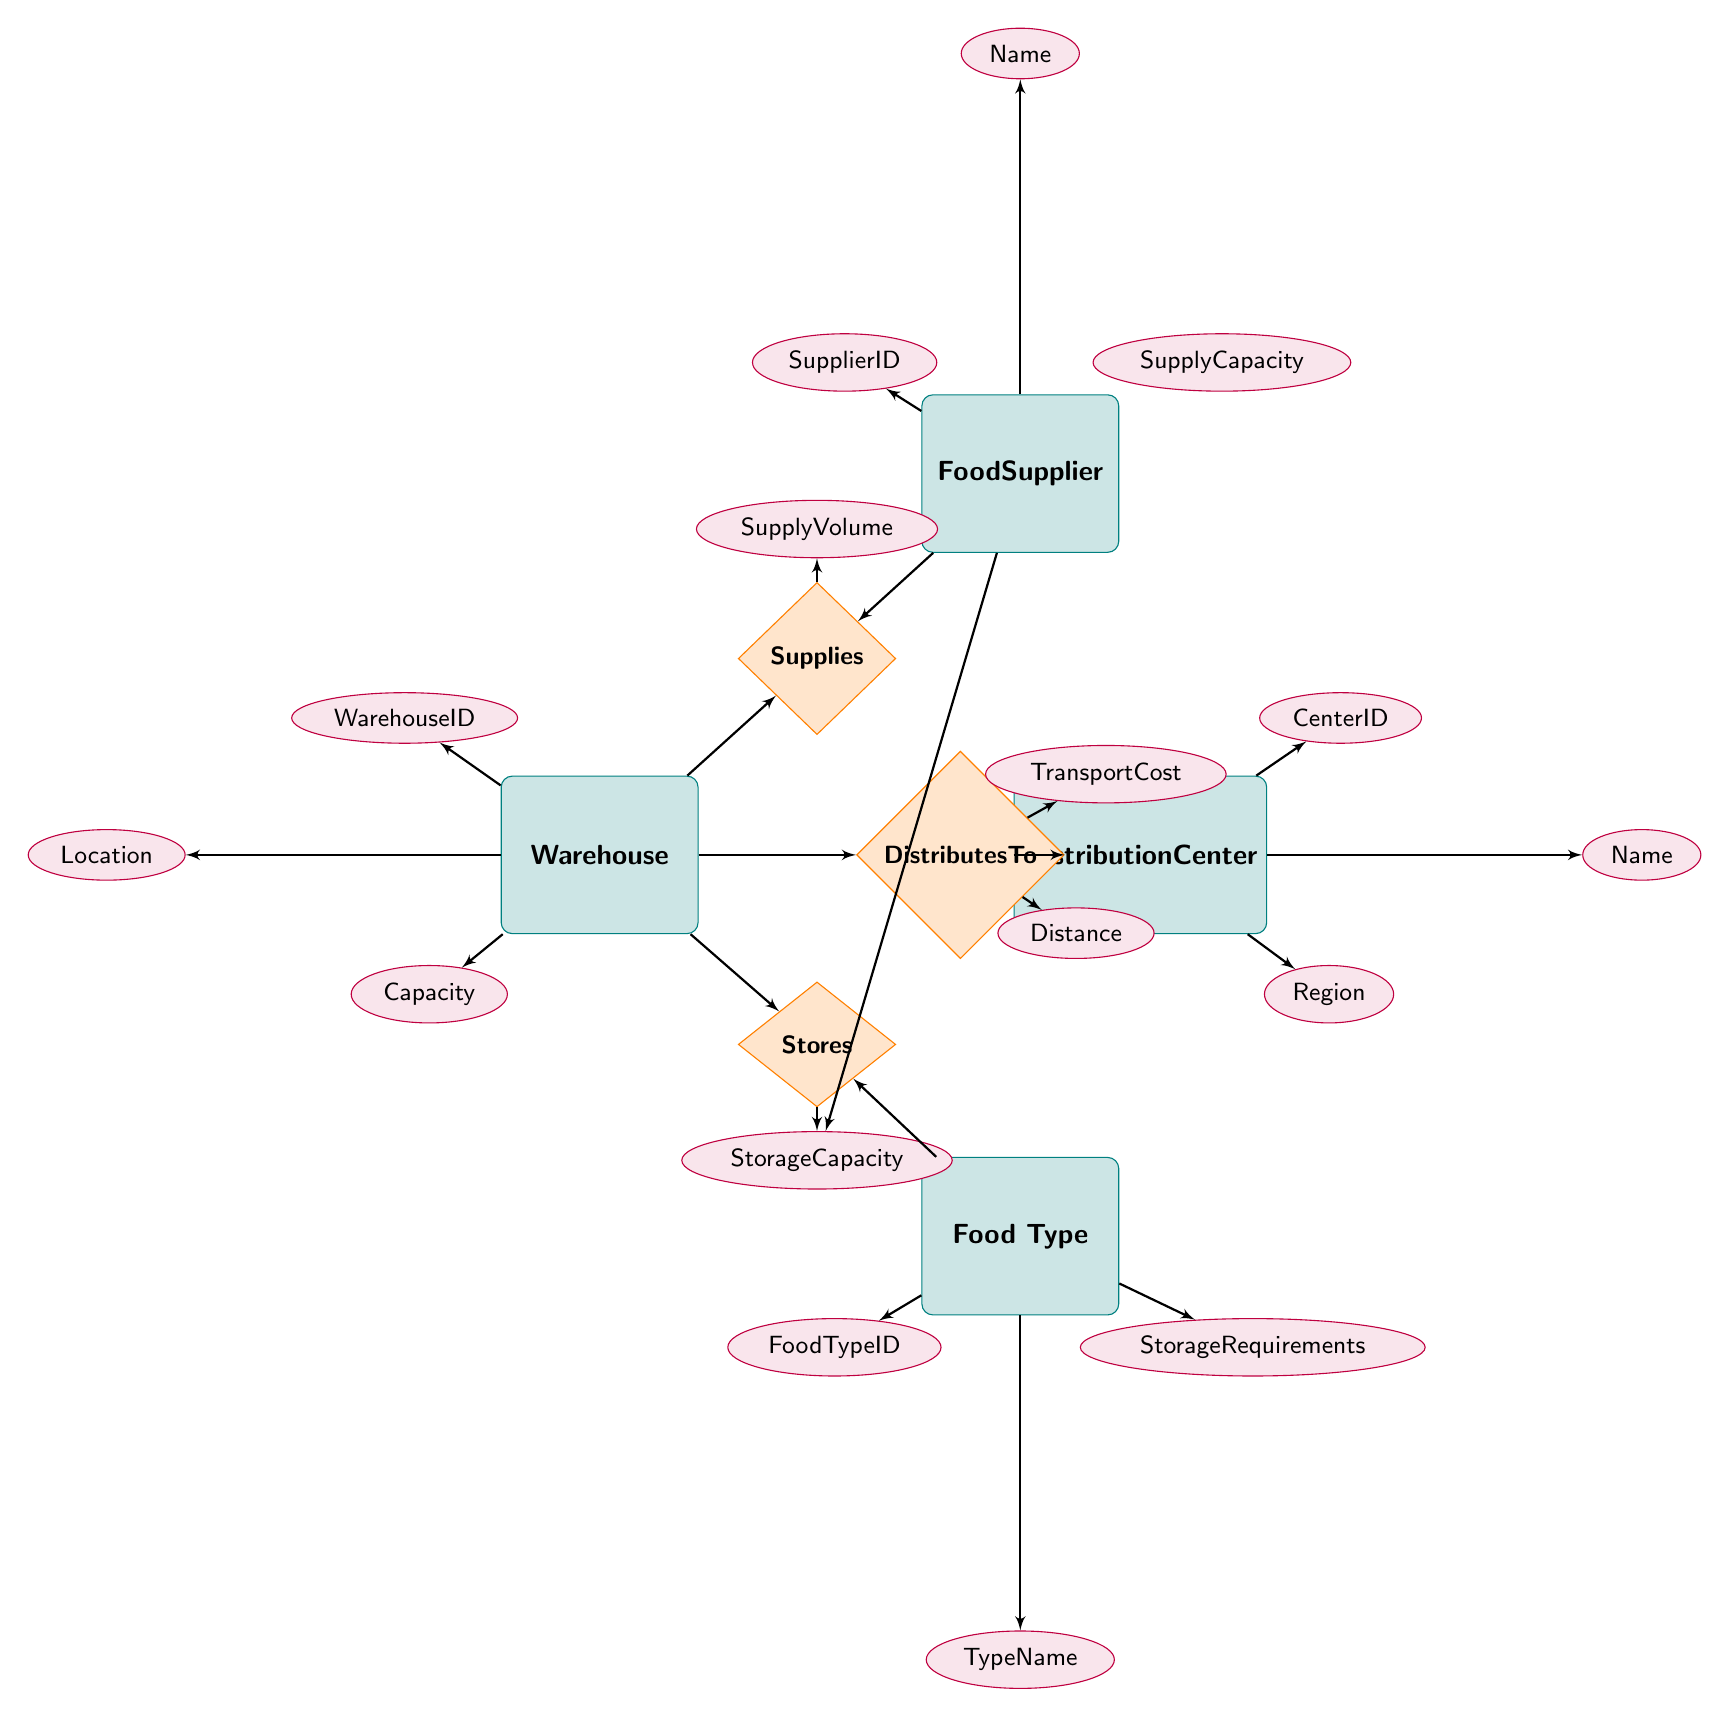What entities are present in the diagram? The diagram includes four entities, which are Warehouse, Food Supplier, Food Type, and Distribution Center.
Answer: Warehouse, Food Supplier, Food Type, Distribution Center How many attributes does the Food Supplier entity have? The Food Supplier entity has three attributes: SupplierID, Name, and SupplyCapacity.
Answer: 3 What relationship connects Food Supplier and Warehouse? The relationship that connects Food Supplier and Warehouse is named Supplies.
Answer: Supplies What is an attribute of the Distributes To relationship? One of the attributes of the Distributes To relationship is TransportCost.
Answer: TransportCost What can you say about the relationship between Warehouse and Food Type? The relationship between Warehouse and Food Type is named Stores, indicating that Warehouses store different types of food.
Answer: Stores How many total attributes are there in the Warehouse entity? The Warehouse entity has three attributes: WarehouseID, Location, and Capacity, totaling three.
Answer: 3 Which entity has a relationship connecting to Distribution Center? The Warehouse entity has a relationship named Distributes To that connects to the Distribution Center entity.
Answer: Warehouse What is the attribute indicating the Distance in the Distributes To relationship? The attribute indicating the Distance in the Distributes To relationship is simply named Distance.
Answer: Distance What is the primary purpose of the Supplies relationship? The Supplies relationship primarily indicates the supply volume from Food Supplier to Warehouse.
Answer: SupplyVolume 